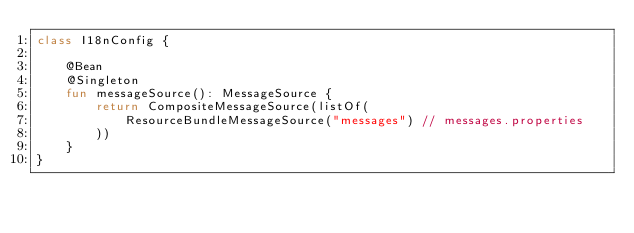<code> <loc_0><loc_0><loc_500><loc_500><_Kotlin_>class I18nConfig {

    @Bean
    @Singleton
    fun messageSource(): MessageSource {
        return CompositeMessageSource(listOf(
            ResourceBundleMessageSource("messages") // messages.properties
        ))
    }
}</code> 